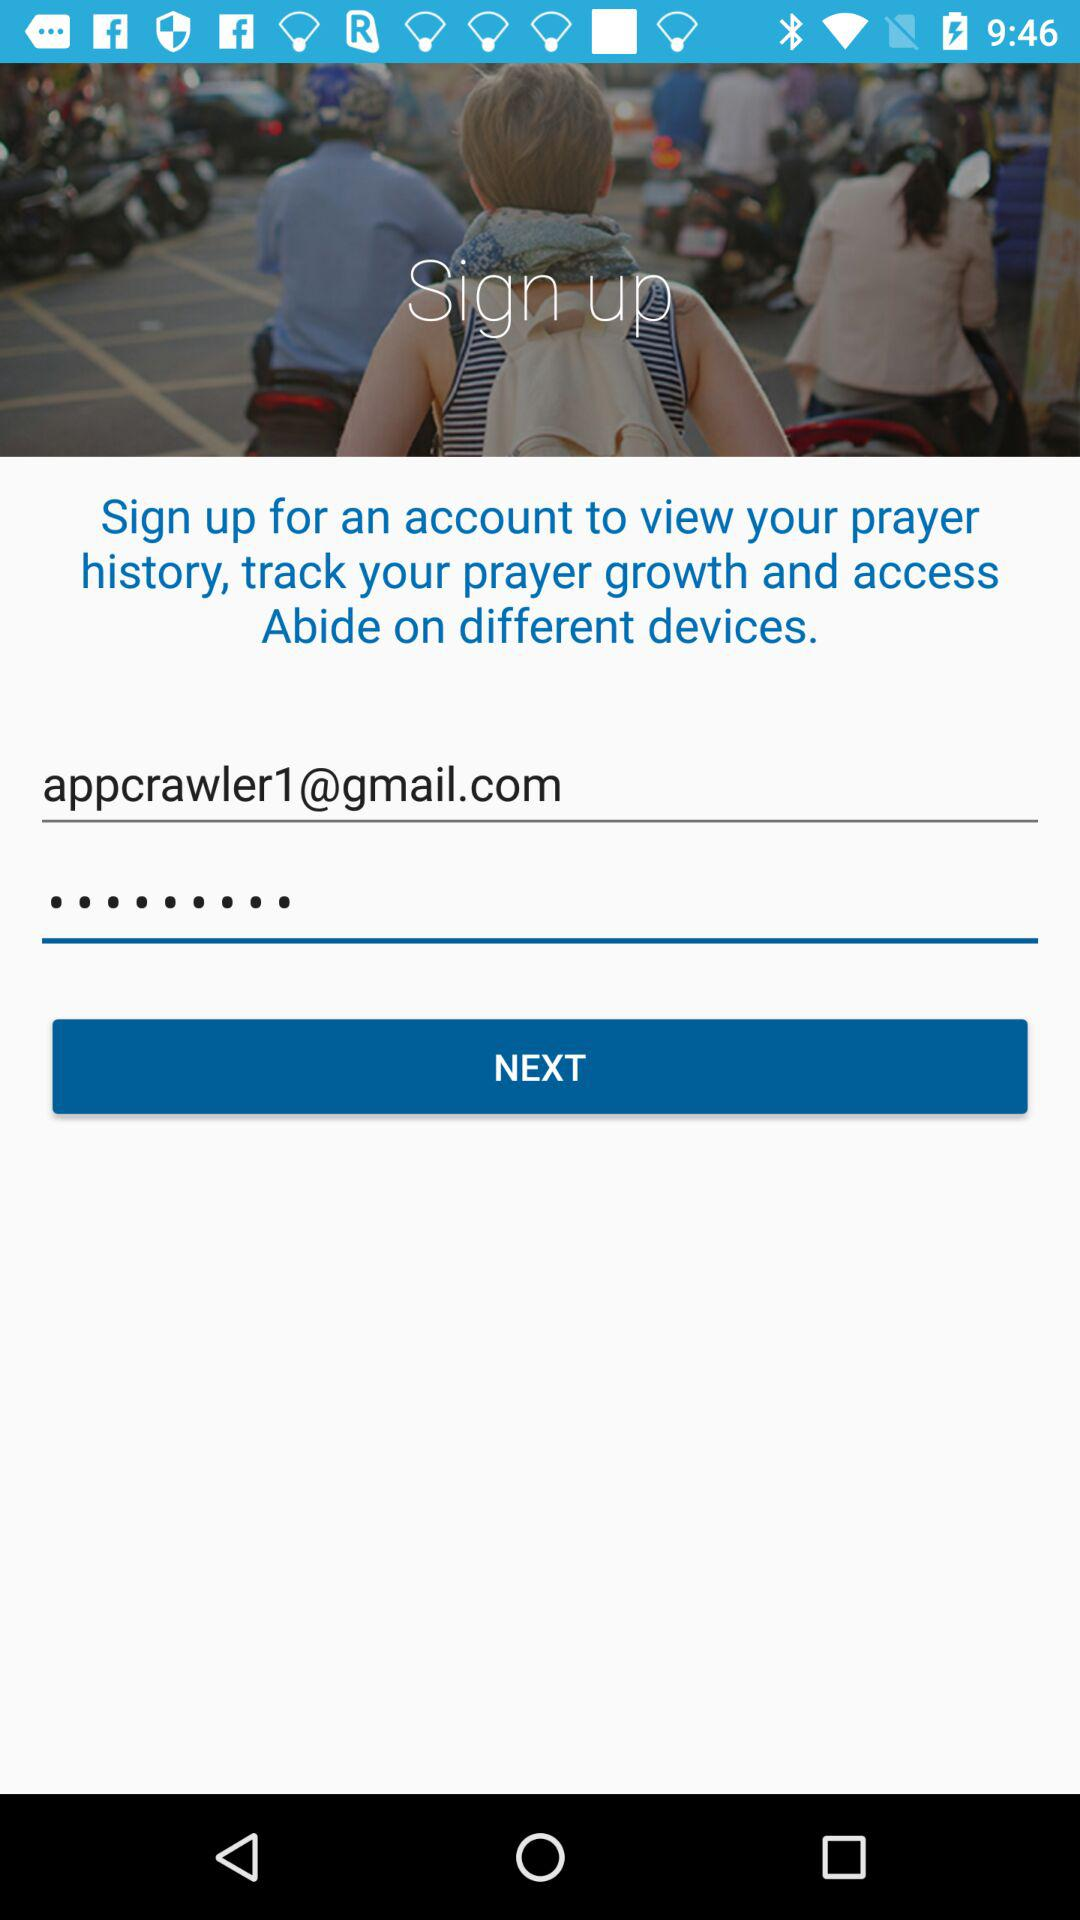What is the email address? The email address is appcrawler1@gmail.com. 